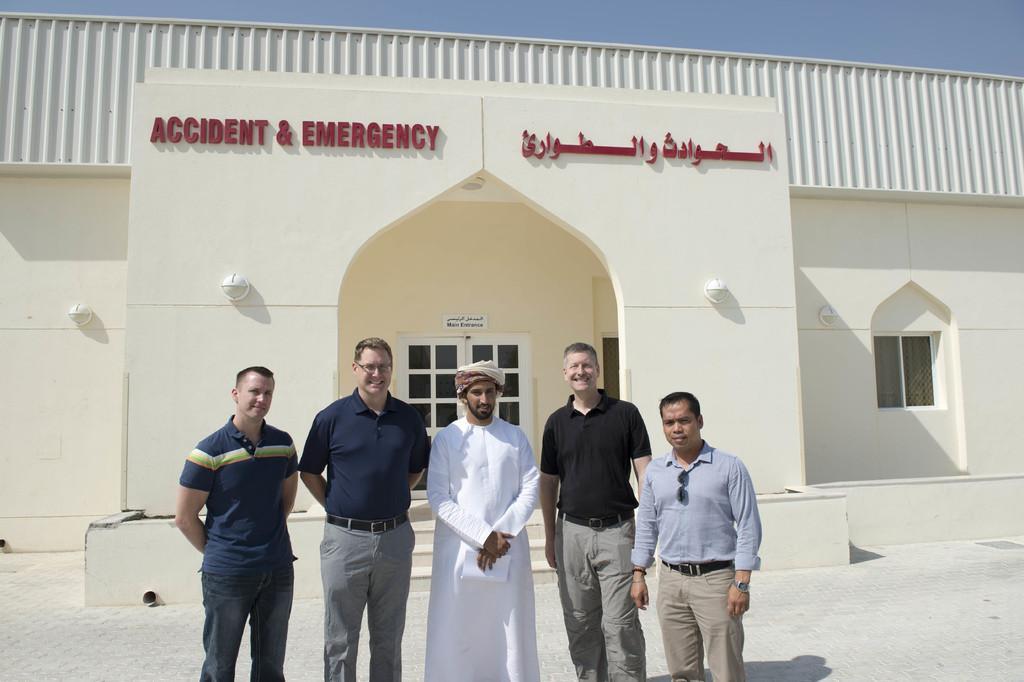Describe this image in one or two sentences. In this picture there are people standing on the ground and we can see building. In the background of the image we can see the sky. 